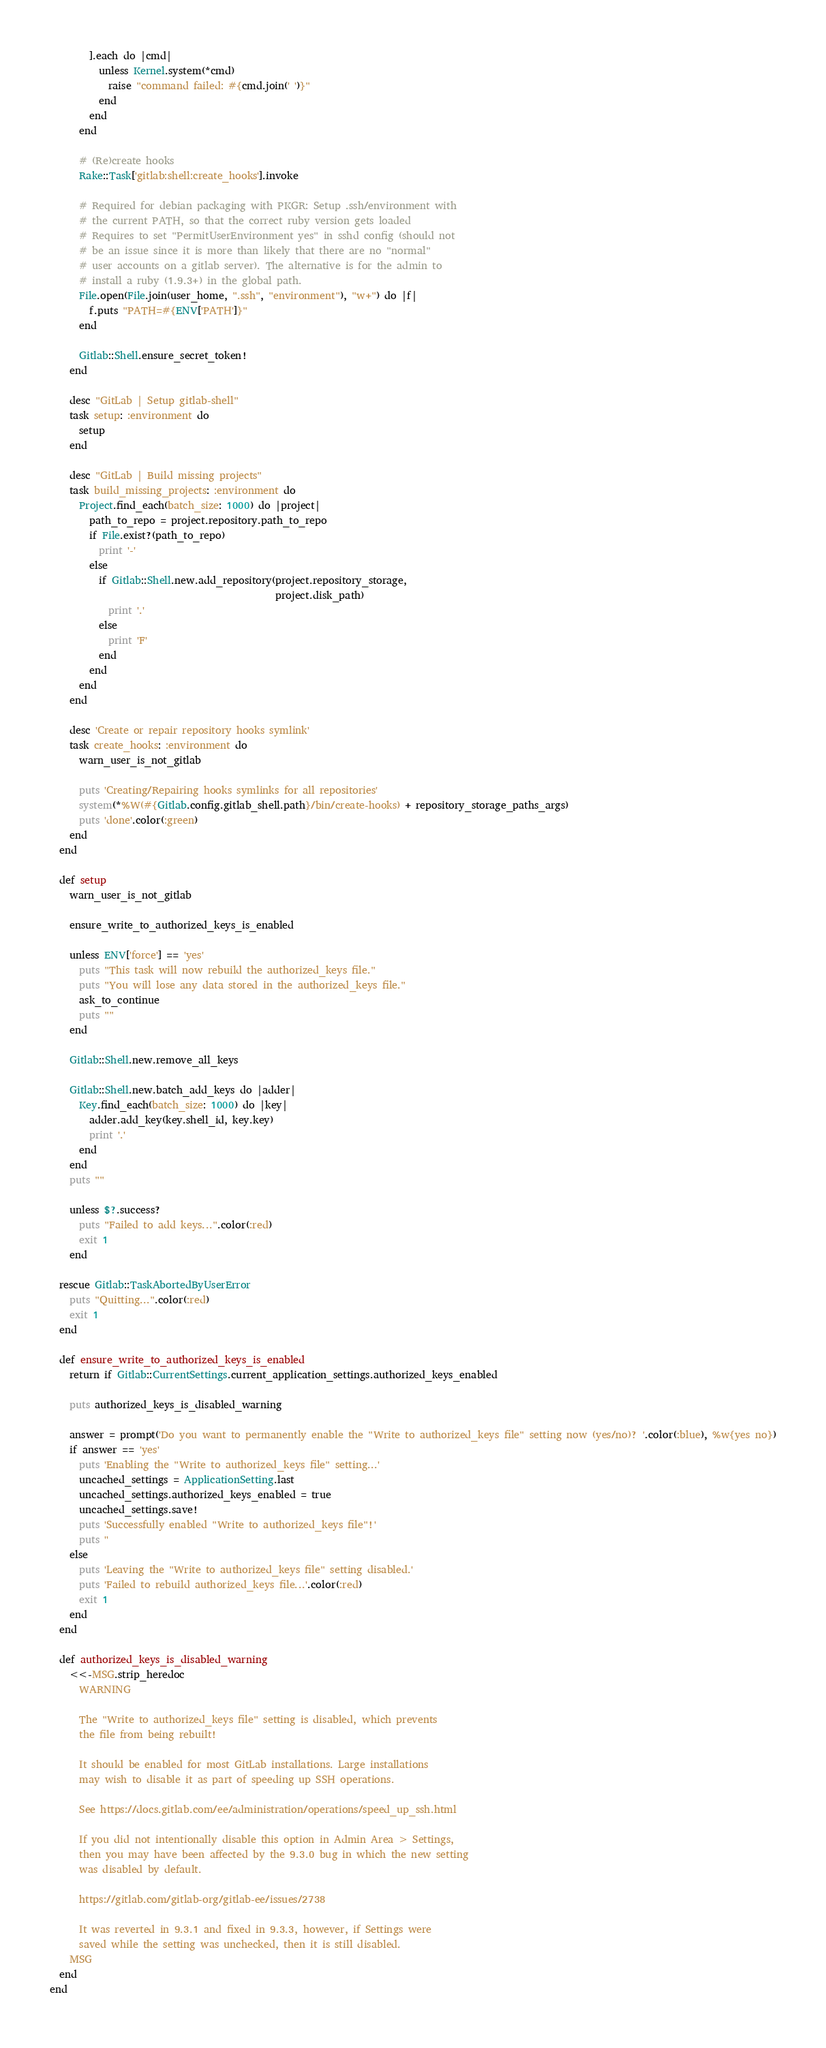Convert code to text. <code><loc_0><loc_0><loc_500><loc_500><_Ruby_>        ].each do |cmd|
          unless Kernel.system(*cmd)
            raise "command failed: #{cmd.join(' ')}"
          end
        end
      end

      # (Re)create hooks
      Rake::Task['gitlab:shell:create_hooks'].invoke

      # Required for debian packaging with PKGR: Setup .ssh/environment with
      # the current PATH, so that the correct ruby version gets loaded
      # Requires to set "PermitUserEnvironment yes" in sshd config (should not
      # be an issue since it is more than likely that there are no "normal"
      # user accounts on a gitlab server). The alternative is for the admin to
      # install a ruby (1.9.3+) in the global path.
      File.open(File.join(user_home, ".ssh", "environment"), "w+") do |f|
        f.puts "PATH=#{ENV['PATH']}"
      end

      Gitlab::Shell.ensure_secret_token!
    end

    desc "GitLab | Setup gitlab-shell"
    task setup: :environment do
      setup
    end

    desc "GitLab | Build missing projects"
    task build_missing_projects: :environment do
      Project.find_each(batch_size: 1000) do |project|
        path_to_repo = project.repository.path_to_repo
        if File.exist?(path_to_repo)
          print '-'
        else
          if Gitlab::Shell.new.add_repository(project.repository_storage,
                                              project.disk_path)
            print '.'
          else
            print 'F'
          end
        end
      end
    end

    desc 'Create or repair repository hooks symlink'
    task create_hooks: :environment do
      warn_user_is_not_gitlab

      puts 'Creating/Repairing hooks symlinks for all repositories'
      system(*%W(#{Gitlab.config.gitlab_shell.path}/bin/create-hooks) + repository_storage_paths_args)
      puts 'done'.color(:green)
    end
  end

  def setup
    warn_user_is_not_gitlab

    ensure_write_to_authorized_keys_is_enabled

    unless ENV['force'] == 'yes'
      puts "This task will now rebuild the authorized_keys file."
      puts "You will lose any data stored in the authorized_keys file."
      ask_to_continue
      puts ""
    end

    Gitlab::Shell.new.remove_all_keys

    Gitlab::Shell.new.batch_add_keys do |adder|
      Key.find_each(batch_size: 1000) do |key|
        adder.add_key(key.shell_id, key.key)
        print '.'
      end
    end
    puts ""

    unless $?.success?
      puts "Failed to add keys...".color(:red)
      exit 1
    end

  rescue Gitlab::TaskAbortedByUserError
    puts "Quitting...".color(:red)
    exit 1
  end

  def ensure_write_to_authorized_keys_is_enabled
    return if Gitlab::CurrentSettings.current_application_settings.authorized_keys_enabled

    puts authorized_keys_is_disabled_warning

    answer = prompt('Do you want to permanently enable the "Write to authorized_keys file" setting now (yes/no)? '.color(:blue), %w{yes no})
    if answer == 'yes'
      puts 'Enabling the "Write to authorized_keys file" setting...'
      uncached_settings = ApplicationSetting.last
      uncached_settings.authorized_keys_enabled = true
      uncached_settings.save!
      puts 'Successfully enabled "Write to authorized_keys file"!'
      puts ''
    else
      puts 'Leaving the "Write to authorized_keys file" setting disabled.'
      puts 'Failed to rebuild authorized_keys file...'.color(:red)
      exit 1
    end
  end

  def authorized_keys_is_disabled_warning
    <<-MSG.strip_heredoc
      WARNING

      The "Write to authorized_keys file" setting is disabled, which prevents
      the file from being rebuilt!

      It should be enabled for most GitLab installations. Large installations
      may wish to disable it as part of speeding up SSH operations.

      See https://docs.gitlab.com/ee/administration/operations/speed_up_ssh.html

      If you did not intentionally disable this option in Admin Area > Settings,
      then you may have been affected by the 9.3.0 bug in which the new setting
      was disabled by default.

      https://gitlab.com/gitlab-org/gitlab-ee/issues/2738

      It was reverted in 9.3.1 and fixed in 9.3.3, however, if Settings were
      saved while the setting was unchecked, then it is still disabled.
    MSG
  end
end
</code> 